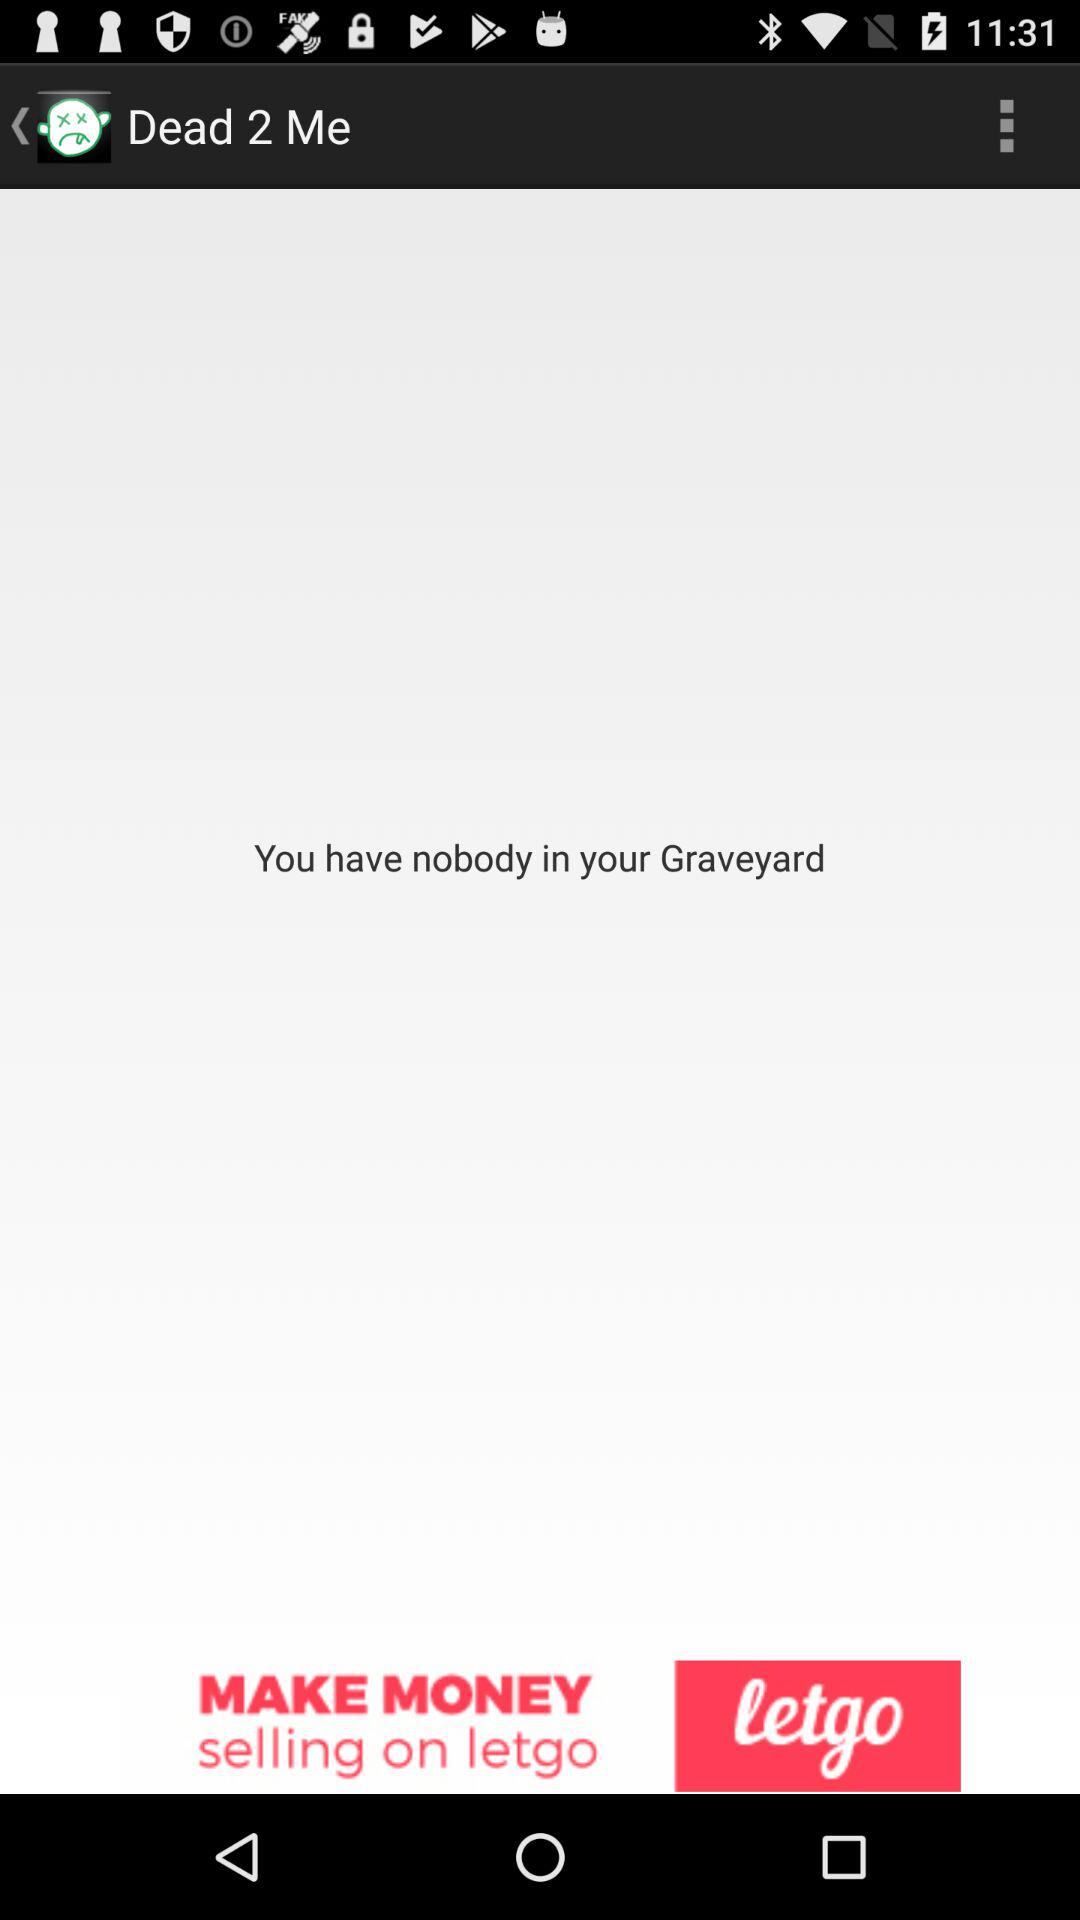Is there anyone shown in the Graveyard? There is nobody shown in the Graveyard. 